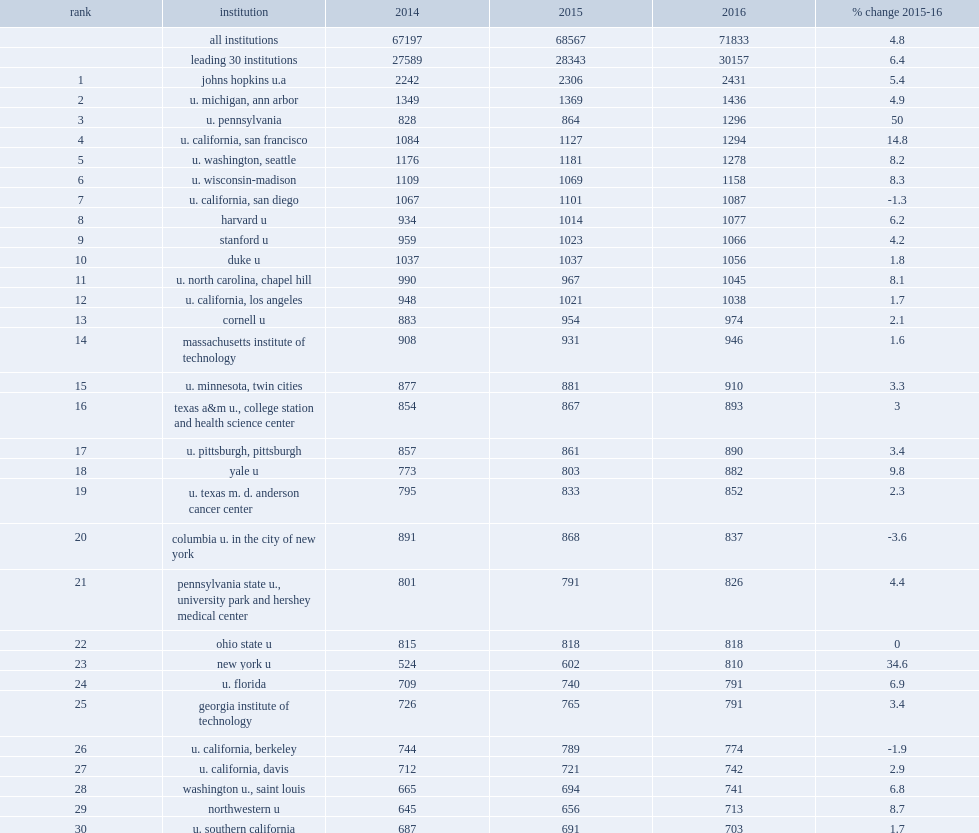New york university rose 12 spots from number 35 in fy 2015 to number 23 in fy 2016, how many percent of increase? 34.6. New york university rose 12 spots from number 35 in fy 2015 to number 23 in fy 2016, how many billion dollars of a increase? 810.0. 